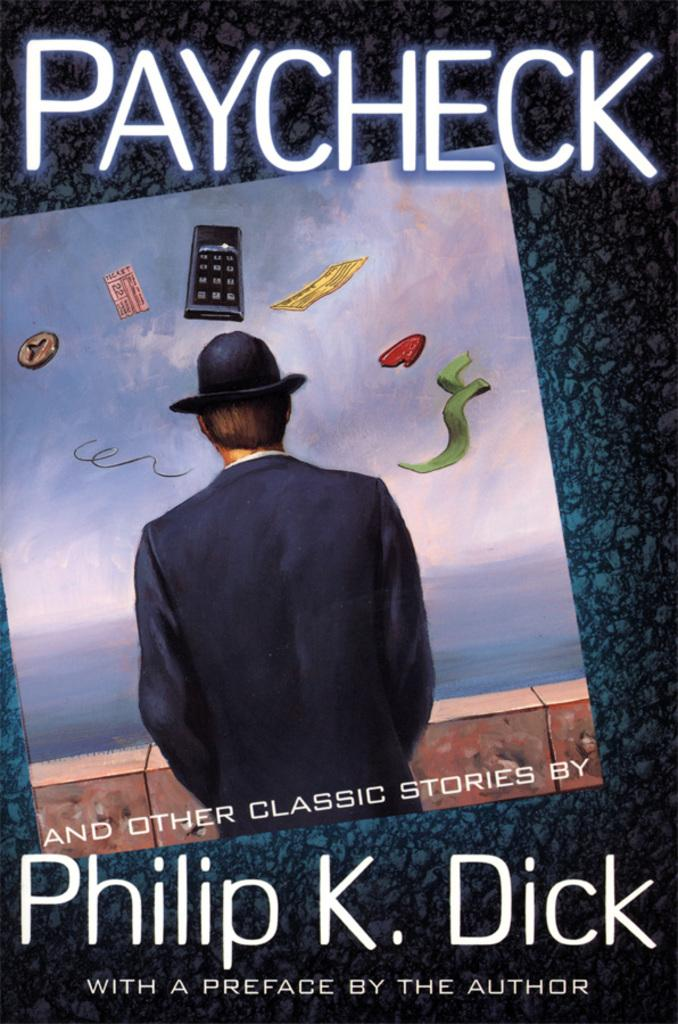<image>
Summarize the visual content of the image. Book cover for PAYCHECK by Philip K. Dick showing a man looking out into the sea. 